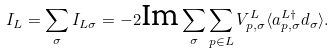<formula> <loc_0><loc_0><loc_500><loc_500>I _ { L } = \sum _ { \sigma } I _ { L \sigma } = - 2 \text {Im} \sum _ { \sigma } \sum _ { p \in L } V ^ { L } _ { p , \sigma } \langle a ^ { L \dagger } _ { p , \sigma } d _ { \sigma } \rangle .</formula> 